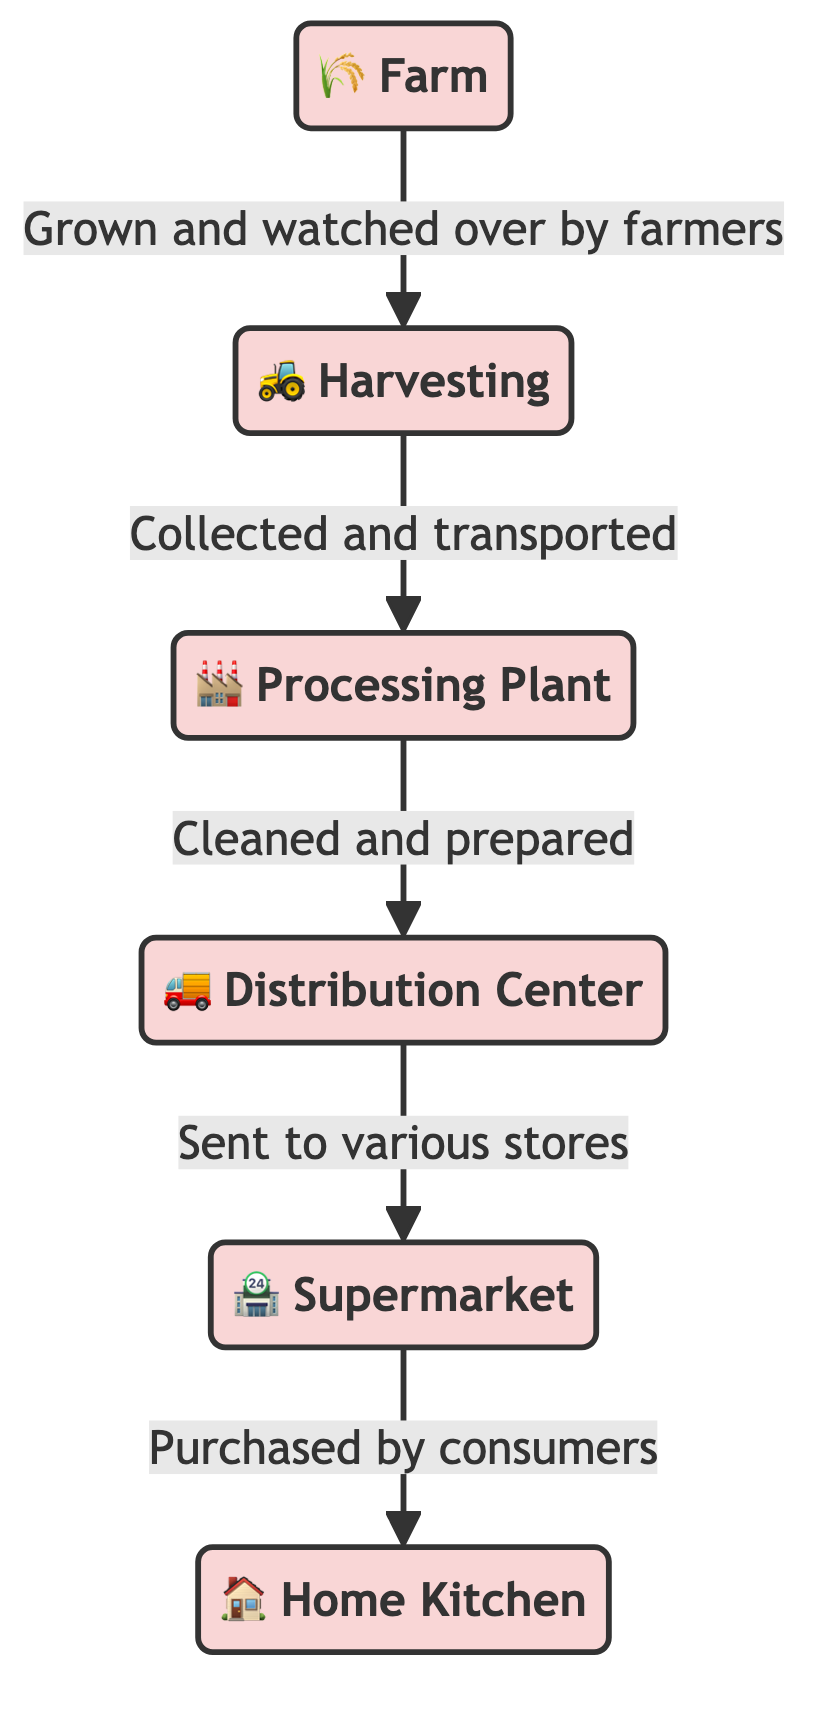What's the first stage of the food chain? The first stage represented in the diagram is "Farm," which is where the journey of the imposter vegetable begins.
Answer: Farm How many nodes are there in the diagram? To find the number of nodes, we count each distinct entity in the flowchart: Farm, Harvesting, Processing Plant, Distribution Center, Supermarket, and Home Kitchen. There are six nodes total.
Answer: 6 What happens after harvesting? After harvesting, the next step indicated in the diagram is "Processing Plant," where the vegetables are cleaned and prepared.
Answer: Processing Plant How do vegetables reach the supermarket? The vegetables move from the "Distribution Center" to the "Supermarket" after being sent to various stores. This indicates the flow from one node to another in the food chain.
Answer: Distribution Center Which node involves the purchase of vegetables? The "Supermarket" is the node where the vegetables are purchased by consumers, marking the transition from store to home.
Answer: Supermarket What is the relationship between the processing plant and the distribution center? The processing plant cleans and prepares the vegetables before they are transported to the distribution center, which showcases a sequential dependency where one step leads into another.
Answer: Sent to various stores What is the last step in the food chain? The last step indicated by the diagram is "Home Kitchen," which is where the vegetables arrive after being purchased by consumers.
Answer: Home Kitchen What type of transportation is used for moving vegetables from the farm to the processing plant? The method for transporting vegetables from the farm to the processing plant is indicated as "Collected and transported," which implies vehicles such as trucks typically used for such a purpose.
Answer: Trucks Which node represents the starting point of the vegetable journey? The starting point of the vegetable journey in the diagram is the "Farm," where they are grown and initially cared for by farmers.
Answer: Farm 